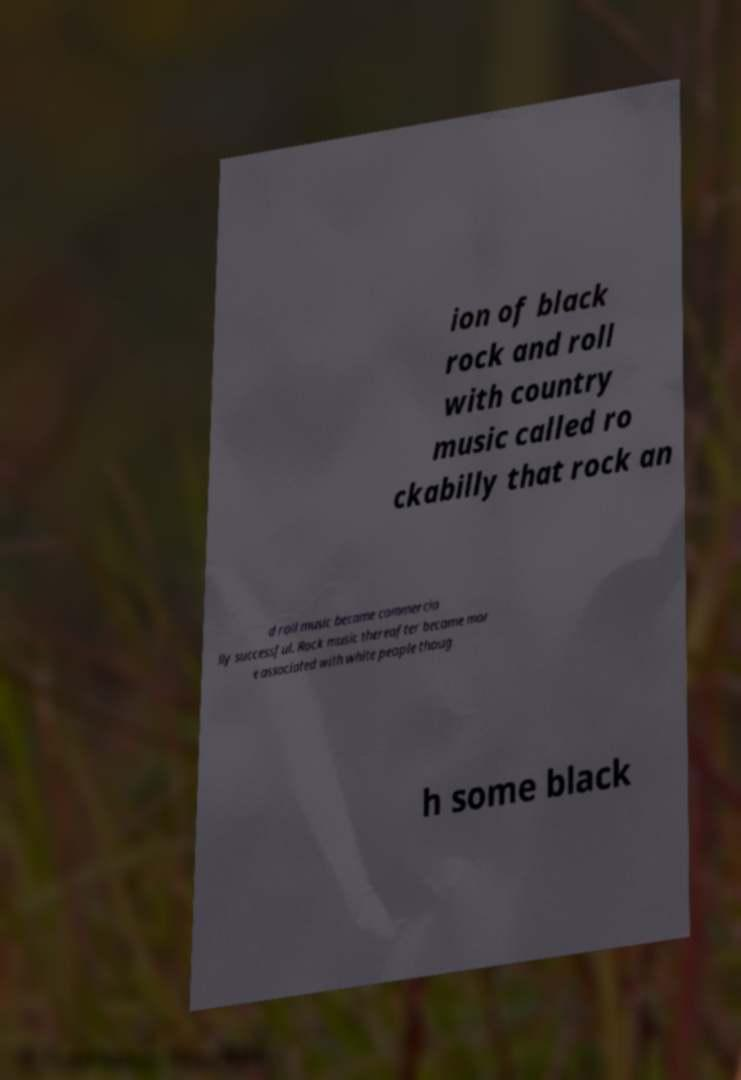What messages or text are displayed in this image? I need them in a readable, typed format. ion of black rock and roll with country music called ro ckabilly that rock an d roll music became commercia lly successful. Rock music thereafter became mor e associated with white people thoug h some black 